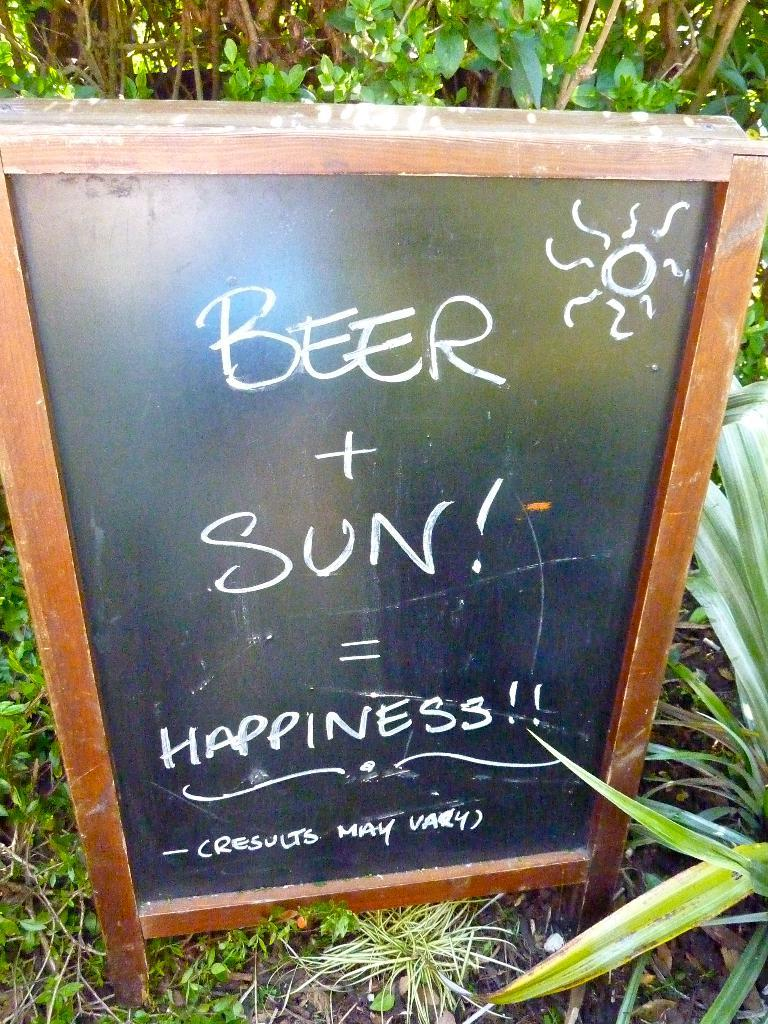What is on the board that is visible in the image? There is a board with writing in the image. What else can be seen near the board? There are plants near the board. What can be seen in the background of the image? There are branches of trees visible in the background of the image. What type of ink is used to write on the board in the image? There is no information about the type of ink used to write on the board in the image. Can you see any insects on the board or plants in the image? There is no mention of insects in the image, so we cannot determine if any are present. 